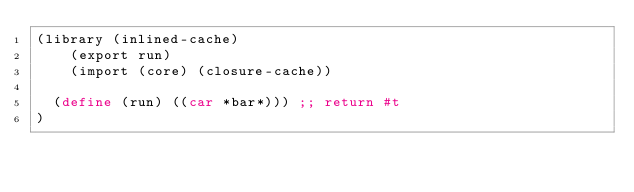<code> <loc_0><loc_0><loc_500><loc_500><_Scheme_>(library (inlined-cache)
    (export run)
    (import (core) (closure-cache))

  (define (run) ((car *bar*))) ;; return #t
)
</code> 